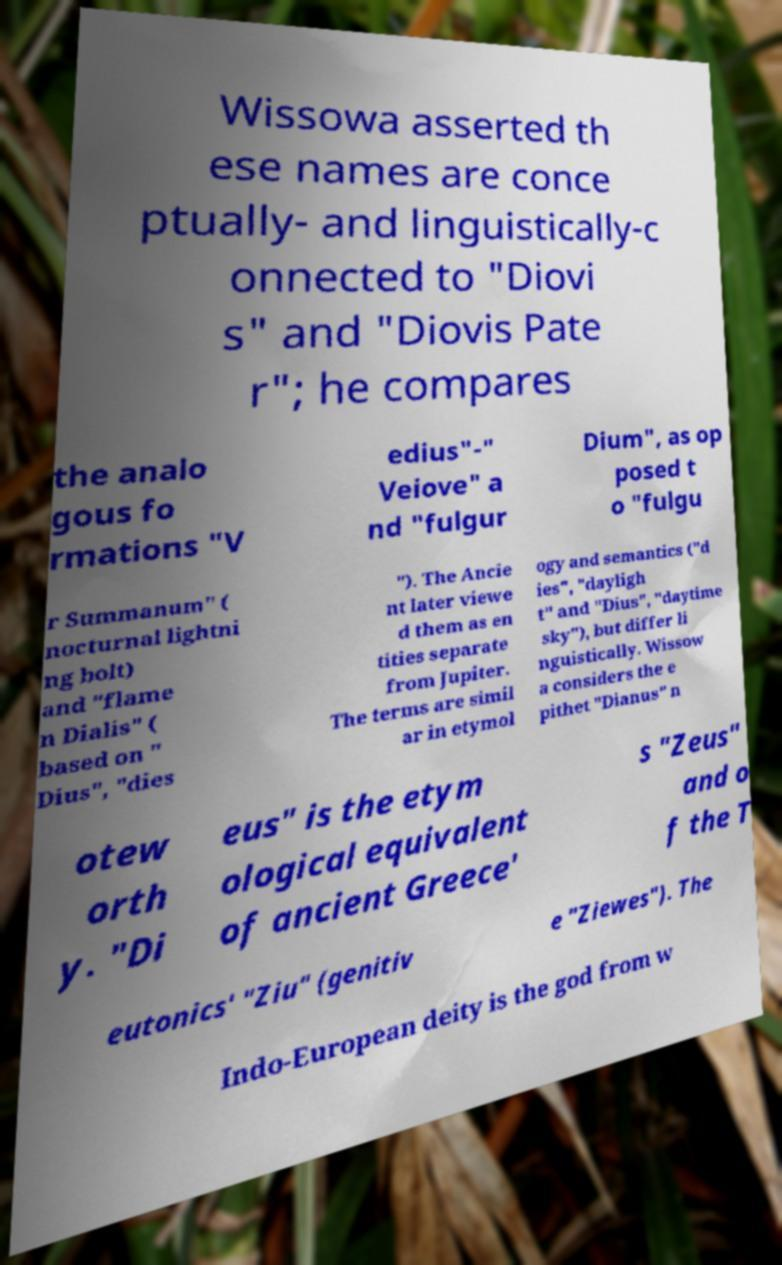Please identify and transcribe the text found in this image. Wissowa asserted th ese names are conce ptually- and linguistically-c onnected to "Diovi s" and "Diovis Pate r"; he compares the analo gous fo rmations "V edius"-" Veiove" a nd "fulgur Dium", as op posed t o "fulgu r Summanum" ( nocturnal lightni ng bolt) and "flame n Dialis" ( based on " Dius", "dies "). The Ancie nt later viewe d them as en tities separate from Jupiter. The terms are simil ar in etymol ogy and semantics ("d ies", "dayligh t" and "Dius", "daytime sky"), but differ li nguistically. Wissow a considers the e pithet "Dianus" n otew orth y. "Di eus" is the etym ological equivalent of ancient Greece' s "Zeus" and o f the T eutonics' "Ziu" (genitiv e "Ziewes"). The Indo-European deity is the god from w 